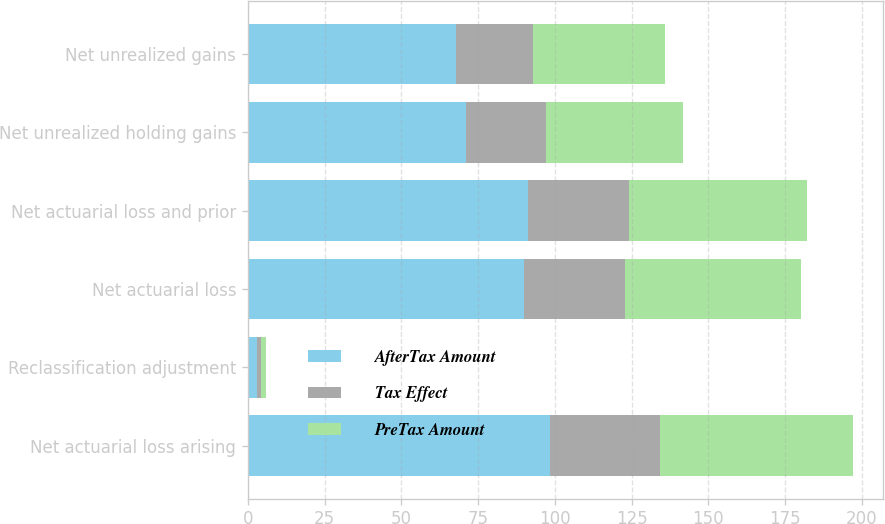Convert chart to OTSL. <chart><loc_0><loc_0><loc_500><loc_500><stacked_bar_chart><ecel><fcel>Net actuarial loss arising<fcel>Reclassification adjustment<fcel>Net actuarial loss<fcel>Net actuarial loss and prior<fcel>Net unrealized holding gains<fcel>Net unrealized gains<nl><fcel>AfterTax Amount<fcel>98.5<fcel>3<fcel>90.1<fcel>91.1<fcel>70.9<fcel>67.9<nl><fcel>Tax Effect<fcel>35.9<fcel>1.2<fcel>32.8<fcel>33.2<fcel>26.3<fcel>25.1<nl><fcel>PreTax Amount<fcel>62.6<fcel>1.8<fcel>57.3<fcel>57.9<fcel>44.6<fcel>42.8<nl></chart> 